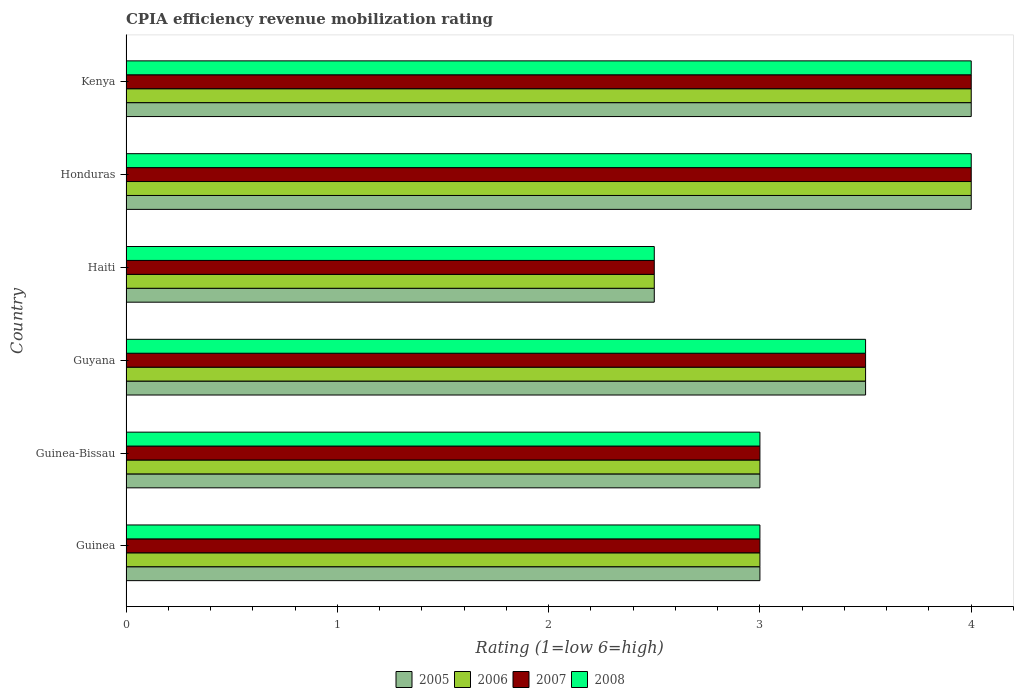How many different coloured bars are there?
Provide a succinct answer. 4. How many bars are there on the 6th tick from the bottom?
Make the answer very short. 4. What is the label of the 2nd group of bars from the top?
Keep it short and to the point. Honduras. In how many cases, is the number of bars for a given country not equal to the number of legend labels?
Your answer should be compact. 0. What is the CPIA rating in 2007 in Guyana?
Offer a very short reply. 3.5. In which country was the CPIA rating in 2005 maximum?
Give a very brief answer. Honduras. In which country was the CPIA rating in 2006 minimum?
Offer a terse response. Haiti. What is the total CPIA rating in 2005 in the graph?
Offer a very short reply. 20. What is the average CPIA rating in 2007 per country?
Make the answer very short. 3.33. In how many countries, is the CPIA rating in 2007 greater than 1.6 ?
Your response must be concise. 6. What is the ratio of the CPIA rating in 2008 in Haiti to that in Kenya?
Ensure brevity in your answer.  0.62. Is the CPIA rating in 2007 in Honduras less than that in Kenya?
Your answer should be very brief. No. What is the difference between the highest and the second highest CPIA rating in 2008?
Keep it short and to the point. 0. What is the difference between the highest and the lowest CPIA rating in 2007?
Provide a succinct answer. 1.5. Is it the case that in every country, the sum of the CPIA rating in 2008 and CPIA rating in 2005 is greater than the sum of CPIA rating in 2007 and CPIA rating in 2006?
Your response must be concise. No. What does the 1st bar from the top in Haiti represents?
Offer a very short reply. 2008. Is it the case that in every country, the sum of the CPIA rating in 2007 and CPIA rating in 2005 is greater than the CPIA rating in 2006?
Offer a terse response. Yes. How many countries are there in the graph?
Offer a very short reply. 6. Does the graph contain any zero values?
Offer a very short reply. No. Does the graph contain grids?
Provide a short and direct response. No. Where does the legend appear in the graph?
Your answer should be compact. Bottom center. How are the legend labels stacked?
Your answer should be very brief. Horizontal. What is the title of the graph?
Provide a short and direct response. CPIA efficiency revenue mobilization rating. What is the label or title of the X-axis?
Provide a succinct answer. Rating (1=low 6=high). What is the Rating (1=low 6=high) of 2007 in Guinea?
Provide a short and direct response. 3. What is the Rating (1=low 6=high) of 2008 in Guinea?
Keep it short and to the point. 3. What is the Rating (1=low 6=high) in 2005 in Guinea-Bissau?
Offer a terse response. 3. What is the Rating (1=low 6=high) of 2006 in Guinea-Bissau?
Offer a very short reply. 3. What is the Rating (1=low 6=high) in 2007 in Guinea-Bissau?
Keep it short and to the point. 3. What is the Rating (1=low 6=high) of 2005 in Guyana?
Give a very brief answer. 3.5. What is the Rating (1=low 6=high) in 2006 in Guyana?
Keep it short and to the point. 3.5. What is the Rating (1=low 6=high) in 2008 in Guyana?
Give a very brief answer. 3.5. What is the Rating (1=low 6=high) in 2007 in Haiti?
Offer a terse response. 2.5. What is the Rating (1=low 6=high) of 2006 in Honduras?
Provide a short and direct response. 4. What is the Rating (1=low 6=high) in 2007 in Honduras?
Ensure brevity in your answer.  4. What is the Rating (1=low 6=high) of 2005 in Kenya?
Offer a terse response. 4. What is the Rating (1=low 6=high) of 2007 in Kenya?
Your answer should be very brief. 4. What is the Rating (1=low 6=high) of 2008 in Kenya?
Your answer should be very brief. 4. Across all countries, what is the maximum Rating (1=low 6=high) in 2005?
Your answer should be very brief. 4. Across all countries, what is the maximum Rating (1=low 6=high) of 2007?
Offer a terse response. 4. Across all countries, what is the maximum Rating (1=low 6=high) in 2008?
Ensure brevity in your answer.  4. Across all countries, what is the minimum Rating (1=low 6=high) of 2005?
Make the answer very short. 2.5. Across all countries, what is the minimum Rating (1=low 6=high) of 2006?
Ensure brevity in your answer.  2.5. Across all countries, what is the minimum Rating (1=low 6=high) of 2007?
Make the answer very short. 2.5. What is the total Rating (1=low 6=high) in 2005 in the graph?
Provide a succinct answer. 20. What is the difference between the Rating (1=low 6=high) in 2005 in Guinea and that in Guinea-Bissau?
Provide a short and direct response. 0. What is the difference between the Rating (1=low 6=high) in 2006 in Guinea and that in Guinea-Bissau?
Offer a terse response. 0. What is the difference between the Rating (1=low 6=high) in 2008 in Guinea and that in Guyana?
Offer a terse response. -0.5. What is the difference between the Rating (1=low 6=high) in 2007 in Guinea and that in Haiti?
Make the answer very short. 0.5. What is the difference between the Rating (1=low 6=high) of 2008 in Guinea and that in Haiti?
Provide a short and direct response. 0.5. What is the difference between the Rating (1=low 6=high) in 2005 in Guinea and that in Honduras?
Give a very brief answer. -1. What is the difference between the Rating (1=low 6=high) of 2006 in Guinea and that in Honduras?
Provide a succinct answer. -1. What is the difference between the Rating (1=low 6=high) in 2008 in Guinea and that in Honduras?
Keep it short and to the point. -1. What is the difference between the Rating (1=low 6=high) of 2007 in Guinea and that in Kenya?
Provide a succinct answer. -1. What is the difference between the Rating (1=low 6=high) of 2005 in Guinea-Bissau and that in Guyana?
Your response must be concise. -0.5. What is the difference between the Rating (1=low 6=high) in 2006 in Guinea-Bissau and that in Guyana?
Give a very brief answer. -0.5. What is the difference between the Rating (1=low 6=high) of 2007 in Guinea-Bissau and that in Guyana?
Offer a very short reply. -0.5. What is the difference between the Rating (1=low 6=high) in 2008 in Guinea-Bissau and that in Guyana?
Keep it short and to the point. -0.5. What is the difference between the Rating (1=low 6=high) in 2005 in Guinea-Bissau and that in Haiti?
Provide a succinct answer. 0.5. What is the difference between the Rating (1=low 6=high) of 2006 in Guinea-Bissau and that in Haiti?
Your response must be concise. 0.5. What is the difference between the Rating (1=low 6=high) in 2008 in Guinea-Bissau and that in Haiti?
Provide a short and direct response. 0.5. What is the difference between the Rating (1=low 6=high) in 2007 in Guinea-Bissau and that in Honduras?
Provide a succinct answer. -1. What is the difference between the Rating (1=low 6=high) of 2005 in Guinea-Bissau and that in Kenya?
Provide a succinct answer. -1. What is the difference between the Rating (1=low 6=high) of 2005 in Guyana and that in Haiti?
Ensure brevity in your answer.  1. What is the difference between the Rating (1=low 6=high) of 2008 in Guyana and that in Haiti?
Your response must be concise. 1. What is the difference between the Rating (1=low 6=high) of 2006 in Guyana and that in Honduras?
Your response must be concise. -0.5. What is the difference between the Rating (1=low 6=high) in 2008 in Guyana and that in Honduras?
Keep it short and to the point. -0.5. What is the difference between the Rating (1=low 6=high) of 2005 in Guyana and that in Kenya?
Keep it short and to the point. -0.5. What is the difference between the Rating (1=low 6=high) in 2006 in Guyana and that in Kenya?
Your answer should be compact. -0.5. What is the difference between the Rating (1=low 6=high) of 2005 in Haiti and that in Honduras?
Provide a short and direct response. -1.5. What is the difference between the Rating (1=low 6=high) in 2006 in Haiti and that in Honduras?
Provide a short and direct response. -1.5. What is the difference between the Rating (1=low 6=high) in 2007 in Haiti and that in Kenya?
Give a very brief answer. -1.5. What is the difference between the Rating (1=low 6=high) of 2008 in Haiti and that in Kenya?
Keep it short and to the point. -1.5. What is the difference between the Rating (1=low 6=high) of 2006 in Honduras and that in Kenya?
Provide a short and direct response. 0. What is the difference between the Rating (1=low 6=high) of 2008 in Honduras and that in Kenya?
Give a very brief answer. 0. What is the difference between the Rating (1=low 6=high) in 2005 in Guinea and the Rating (1=low 6=high) in 2006 in Guinea-Bissau?
Ensure brevity in your answer.  0. What is the difference between the Rating (1=low 6=high) in 2005 in Guinea and the Rating (1=low 6=high) in 2007 in Guinea-Bissau?
Give a very brief answer. 0. What is the difference between the Rating (1=low 6=high) of 2006 in Guinea and the Rating (1=low 6=high) of 2008 in Guinea-Bissau?
Provide a succinct answer. 0. What is the difference between the Rating (1=low 6=high) of 2005 in Guinea and the Rating (1=low 6=high) of 2007 in Guyana?
Your response must be concise. -0.5. What is the difference between the Rating (1=low 6=high) in 2005 in Guinea and the Rating (1=low 6=high) in 2008 in Guyana?
Give a very brief answer. -0.5. What is the difference between the Rating (1=low 6=high) of 2005 in Guinea and the Rating (1=low 6=high) of 2008 in Haiti?
Ensure brevity in your answer.  0.5. What is the difference between the Rating (1=low 6=high) of 2005 in Guinea and the Rating (1=low 6=high) of 2006 in Honduras?
Give a very brief answer. -1. What is the difference between the Rating (1=low 6=high) in 2006 in Guinea and the Rating (1=low 6=high) in 2007 in Honduras?
Your answer should be very brief. -1. What is the difference between the Rating (1=low 6=high) of 2005 in Guinea and the Rating (1=low 6=high) of 2008 in Kenya?
Offer a very short reply. -1. What is the difference between the Rating (1=low 6=high) in 2006 in Guinea and the Rating (1=low 6=high) in 2007 in Kenya?
Keep it short and to the point. -1. What is the difference between the Rating (1=low 6=high) of 2006 in Guinea and the Rating (1=low 6=high) of 2008 in Kenya?
Offer a terse response. -1. What is the difference between the Rating (1=low 6=high) of 2007 in Guinea-Bissau and the Rating (1=low 6=high) of 2008 in Guyana?
Keep it short and to the point. -0.5. What is the difference between the Rating (1=low 6=high) in 2005 in Guinea-Bissau and the Rating (1=low 6=high) in 2008 in Haiti?
Offer a very short reply. 0.5. What is the difference between the Rating (1=low 6=high) of 2005 in Guinea-Bissau and the Rating (1=low 6=high) of 2006 in Honduras?
Keep it short and to the point. -1. What is the difference between the Rating (1=low 6=high) in 2005 in Guinea-Bissau and the Rating (1=low 6=high) in 2007 in Honduras?
Offer a terse response. -1. What is the difference between the Rating (1=low 6=high) of 2005 in Guinea-Bissau and the Rating (1=low 6=high) of 2006 in Kenya?
Give a very brief answer. -1. What is the difference between the Rating (1=low 6=high) in 2006 in Guinea-Bissau and the Rating (1=low 6=high) in 2007 in Kenya?
Offer a very short reply. -1. What is the difference between the Rating (1=low 6=high) of 2005 in Guyana and the Rating (1=low 6=high) of 2007 in Haiti?
Your answer should be compact. 1. What is the difference between the Rating (1=low 6=high) in 2006 in Guyana and the Rating (1=low 6=high) in 2007 in Haiti?
Make the answer very short. 1. What is the difference between the Rating (1=low 6=high) of 2005 in Guyana and the Rating (1=low 6=high) of 2006 in Honduras?
Ensure brevity in your answer.  -0.5. What is the difference between the Rating (1=low 6=high) of 2005 in Guyana and the Rating (1=low 6=high) of 2007 in Honduras?
Ensure brevity in your answer.  -0.5. What is the difference between the Rating (1=low 6=high) in 2005 in Guyana and the Rating (1=low 6=high) in 2008 in Kenya?
Your answer should be very brief. -0.5. What is the difference between the Rating (1=low 6=high) of 2006 in Guyana and the Rating (1=low 6=high) of 2008 in Kenya?
Your response must be concise. -0.5. What is the difference between the Rating (1=low 6=high) of 2007 in Haiti and the Rating (1=low 6=high) of 2008 in Honduras?
Your answer should be compact. -1.5. What is the difference between the Rating (1=low 6=high) of 2005 in Haiti and the Rating (1=low 6=high) of 2007 in Kenya?
Give a very brief answer. -1.5. What is the difference between the Rating (1=low 6=high) of 2006 in Haiti and the Rating (1=low 6=high) of 2008 in Kenya?
Make the answer very short. -1.5. What is the difference between the Rating (1=low 6=high) in 2005 in Honduras and the Rating (1=low 6=high) in 2006 in Kenya?
Offer a very short reply. 0. What is the difference between the Rating (1=low 6=high) of 2005 in Honduras and the Rating (1=low 6=high) of 2008 in Kenya?
Keep it short and to the point. 0. What is the difference between the Rating (1=low 6=high) of 2006 in Honduras and the Rating (1=low 6=high) of 2008 in Kenya?
Ensure brevity in your answer.  0. What is the average Rating (1=low 6=high) of 2007 per country?
Your response must be concise. 3.33. What is the average Rating (1=low 6=high) in 2008 per country?
Your answer should be compact. 3.33. What is the difference between the Rating (1=low 6=high) in 2005 and Rating (1=low 6=high) in 2007 in Guinea?
Offer a terse response. 0. What is the difference between the Rating (1=low 6=high) in 2006 and Rating (1=low 6=high) in 2008 in Guinea?
Provide a short and direct response. 0. What is the difference between the Rating (1=low 6=high) in 2005 and Rating (1=low 6=high) in 2007 in Guinea-Bissau?
Provide a succinct answer. 0. What is the difference between the Rating (1=low 6=high) of 2006 and Rating (1=low 6=high) of 2008 in Guinea-Bissau?
Offer a very short reply. 0. What is the difference between the Rating (1=low 6=high) of 2005 and Rating (1=low 6=high) of 2006 in Guyana?
Give a very brief answer. 0. What is the difference between the Rating (1=low 6=high) of 2006 and Rating (1=low 6=high) of 2007 in Guyana?
Make the answer very short. 0. What is the difference between the Rating (1=low 6=high) of 2006 and Rating (1=low 6=high) of 2008 in Guyana?
Offer a very short reply. 0. What is the difference between the Rating (1=low 6=high) of 2005 and Rating (1=low 6=high) of 2006 in Haiti?
Your response must be concise. 0. What is the difference between the Rating (1=low 6=high) in 2005 and Rating (1=low 6=high) in 2007 in Haiti?
Make the answer very short. 0. What is the difference between the Rating (1=low 6=high) of 2005 and Rating (1=low 6=high) of 2008 in Haiti?
Your response must be concise. 0. What is the difference between the Rating (1=low 6=high) in 2007 and Rating (1=low 6=high) in 2008 in Haiti?
Your response must be concise. 0. What is the difference between the Rating (1=low 6=high) of 2005 and Rating (1=low 6=high) of 2007 in Honduras?
Keep it short and to the point. 0. What is the difference between the Rating (1=low 6=high) in 2005 and Rating (1=low 6=high) in 2008 in Honduras?
Provide a short and direct response. 0. What is the difference between the Rating (1=low 6=high) in 2007 and Rating (1=low 6=high) in 2008 in Honduras?
Offer a terse response. 0. What is the difference between the Rating (1=low 6=high) in 2005 and Rating (1=low 6=high) in 2008 in Kenya?
Offer a terse response. 0. What is the difference between the Rating (1=low 6=high) of 2006 and Rating (1=low 6=high) of 2008 in Kenya?
Your answer should be compact. 0. What is the difference between the Rating (1=low 6=high) in 2007 and Rating (1=low 6=high) in 2008 in Kenya?
Make the answer very short. 0. What is the ratio of the Rating (1=low 6=high) in 2007 in Guinea to that in Guinea-Bissau?
Keep it short and to the point. 1. What is the ratio of the Rating (1=low 6=high) in 2006 in Guinea to that in Guyana?
Provide a short and direct response. 0.86. What is the ratio of the Rating (1=low 6=high) in 2008 in Guinea to that in Guyana?
Give a very brief answer. 0.86. What is the ratio of the Rating (1=low 6=high) in 2008 in Guinea to that in Haiti?
Your answer should be very brief. 1.2. What is the ratio of the Rating (1=low 6=high) of 2005 in Guinea to that in Kenya?
Offer a very short reply. 0.75. What is the ratio of the Rating (1=low 6=high) of 2006 in Guinea to that in Kenya?
Offer a very short reply. 0.75. What is the ratio of the Rating (1=low 6=high) of 2007 in Guinea to that in Kenya?
Ensure brevity in your answer.  0.75. What is the ratio of the Rating (1=low 6=high) of 2007 in Guinea-Bissau to that in Guyana?
Ensure brevity in your answer.  0.86. What is the ratio of the Rating (1=low 6=high) in 2008 in Guinea-Bissau to that in Guyana?
Your answer should be compact. 0.86. What is the ratio of the Rating (1=low 6=high) in 2008 in Guinea-Bissau to that in Haiti?
Offer a terse response. 1.2. What is the ratio of the Rating (1=low 6=high) in 2005 in Guinea-Bissau to that in Honduras?
Offer a terse response. 0.75. What is the ratio of the Rating (1=low 6=high) in 2006 in Guinea-Bissau to that in Honduras?
Offer a very short reply. 0.75. What is the ratio of the Rating (1=low 6=high) of 2007 in Guinea-Bissau to that in Honduras?
Your answer should be compact. 0.75. What is the ratio of the Rating (1=low 6=high) in 2008 in Guinea-Bissau to that in Honduras?
Offer a very short reply. 0.75. What is the ratio of the Rating (1=low 6=high) in 2006 in Guinea-Bissau to that in Kenya?
Your response must be concise. 0.75. What is the ratio of the Rating (1=low 6=high) of 2006 in Guyana to that in Haiti?
Provide a succinct answer. 1.4. What is the ratio of the Rating (1=low 6=high) in 2007 in Guyana to that in Haiti?
Your answer should be compact. 1.4. What is the ratio of the Rating (1=low 6=high) of 2008 in Guyana to that in Haiti?
Your answer should be very brief. 1.4. What is the ratio of the Rating (1=low 6=high) of 2007 in Guyana to that in Honduras?
Ensure brevity in your answer.  0.88. What is the ratio of the Rating (1=low 6=high) in 2006 in Guyana to that in Kenya?
Provide a short and direct response. 0.88. What is the ratio of the Rating (1=low 6=high) of 2008 in Guyana to that in Kenya?
Provide a succinct answer. 0.88. What is the ratio of the Rating (1=low 6=high) of 2005 in Haiti to that in Honduras?
Offer a very short reply. 0.62. What is the ratio of the Rating (1=low 6=high) in 2007 in Haiti to that in Honduras?
Make the answer very short. 0.62. What is the ratio of the Rating (1=low 6=high) in 2005 in Haiti to that in Kenya?
Offer a very short reply. 0.62. What is the ratio of the Rating (1=low 6=high) in 2008 in Haiti to that in Kenya?
Provide a short and direct response. 0.62. What is the ratio of the Rating (1=low 6=high) of 2005 in Honduras to that in Kenya?
Ensure brevity in your answer.  1. What is the ratio of the Rating (1=low 6=high) of 2006 in Honduras to that in Kenya?
Offer a terse response. 1. What is the ratio of the Rating (1=low 6=high) in 2007 in Honduras to that in Kenya?
Ensure brevity in your answer.  1. What is the ratio of the Rating (1=low 6=high) in 2008 in Honduras to that in Kenya?
Your answer should be compact. 1. What is the difference between the highest and the second highest Rating (1=low 6=high) in 2006?
Your answer should be compact. 0. What is the difference between the highest and the lowest Rating (1=low 6=high) in 2005?
Your answer should be compact. 1.5. What is the difference between the highest and the lowest Rating (1=low 6=high) in 2006?
Make the answer very short. 1.5. 